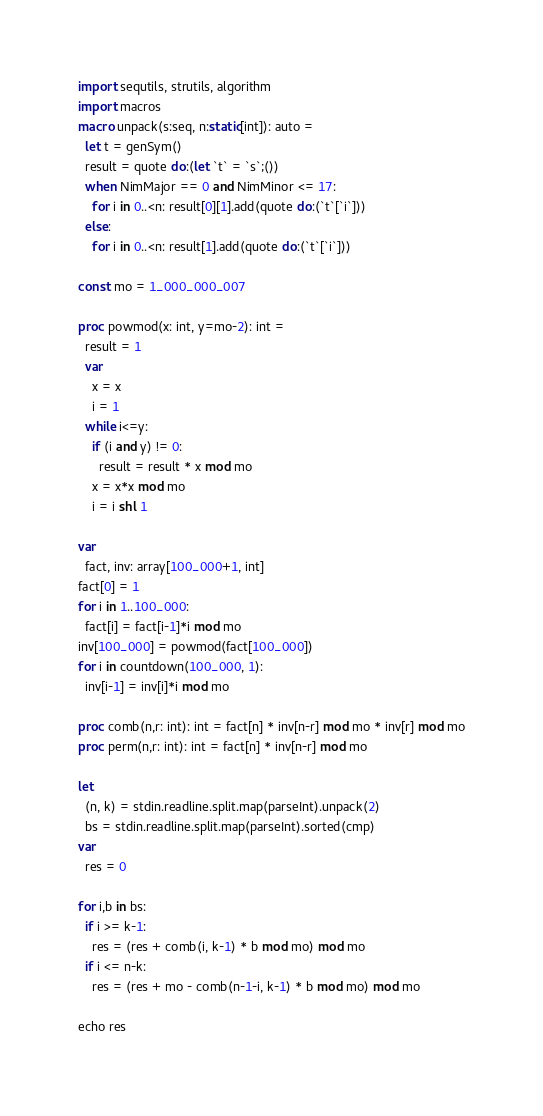<code> <loc_0><loc_0><loc_500><loc_500><_Nim_>import sequtils, strutils, algorithm
import macros
macro unpack(s:seq, n:static[int]): auto =
  let t = genSym()
  result = quote do:(let `t` = `s`;())
  when NimMajor == 0 and NimMinor <= 17:
    for i in 0..<n: result[0][1].add(quote do:(`t`[`i`]))
  else:
    for i in 0..<n: result[1].add(quote do:(`t`[`i`]))

const mo = 1_000_000_007

proc powmod(x: int, y=mo-2): int =
  result = 1
  var
    x = x
    i = 1
  while i<=y:
    if (i and y) != 0:
      result = result * x mod mo
    x = x*x mod mo
    i = i shl 1

var
  fact, inv: array[100_000+1, int]
fact[0] = 1
for i in 1..100_000:
  fact[i] = fact[i-1]*i mod mo
inv[100_000] = powmod(fact[100_000])
for i in countdown(100_000, 1):
  inv[i-1] = inv[i]*i mod mo

proc comb(n,r: int): int = fact[n] * inv[n-r] mod mo * inv[r] mod mo
proc perm(n,r: int): int = fact[n] * inv[n-r] mod mo

let
  (n, k) = stdin.readline.split.map(parseInt).unpack(2)
  bs = stdin.readline.split.map(parseInt).sorted(cmp)
var
  res = 0

for i,b in bs:
  if i >= k-1:
    res = (res + comb(i, k-1) * b mod mo) mod mo
  if i <= n-k:
    res = (res + mo - comb(n-1-i, k-1) * b mod mo) mod mo

echo res
</code> 